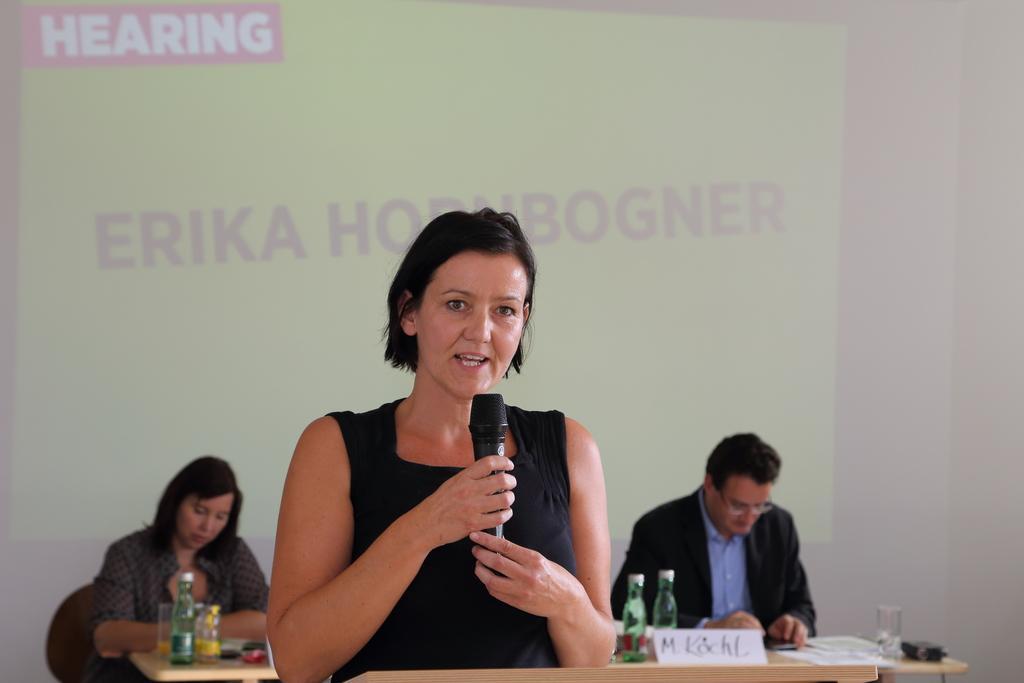Can you describe this image briefly? In this image the women in the foreground is holding a mic in her hands and speaking. She is wearing a black dress. In the background there are two people who is sitting on the chair and looking down. There is a table and few bottles and glasses are placed on the table. In the background there is a screen projected on the wall. 